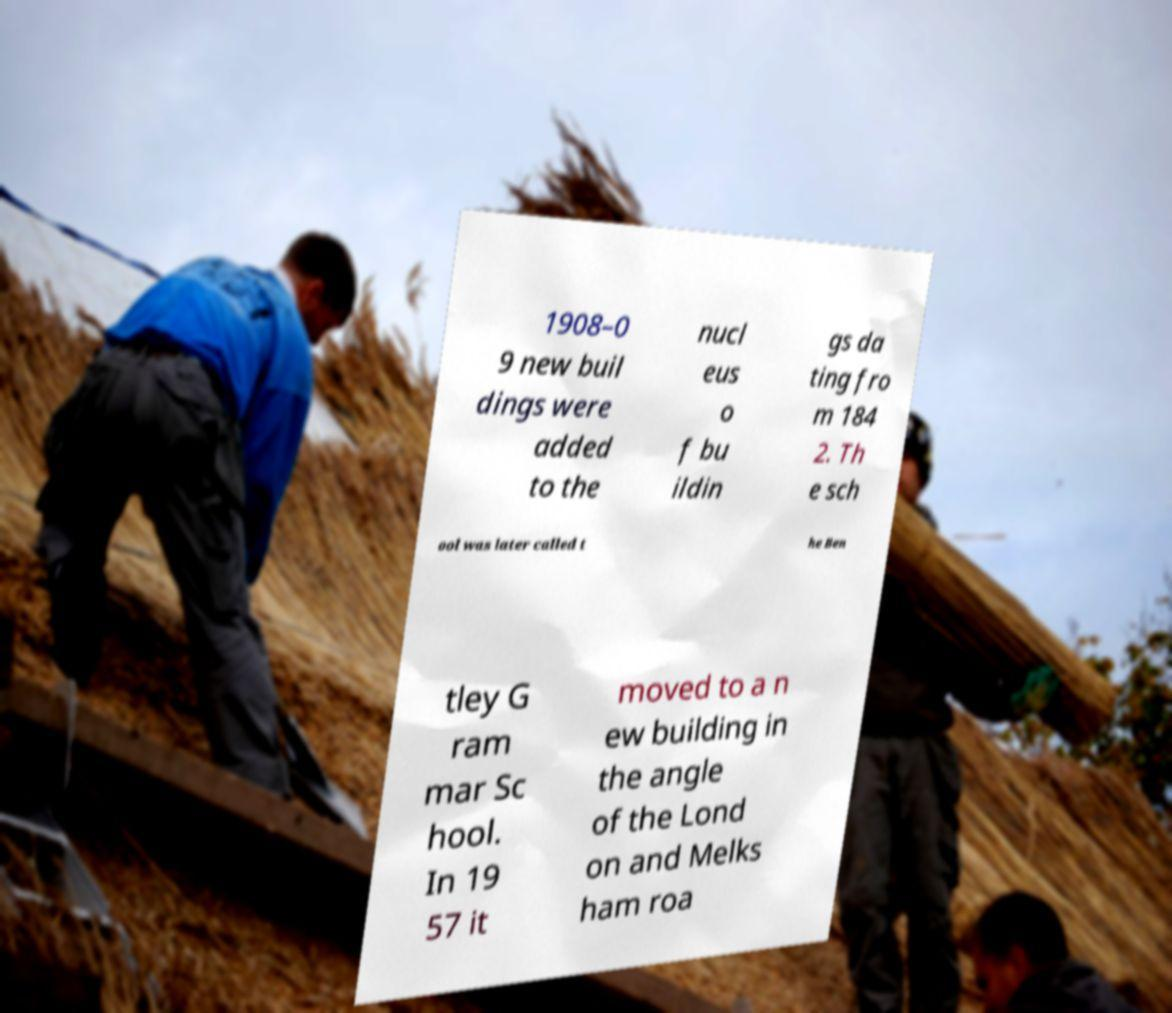What messages or text are displayed in this image? I need them in a readable, typed format. 1908–0 9 new buil dings were added to the nucl eus o f bu ildin gs da ting fro m 184 2. Th e sch ool was later called t he Ben tley G ram mar Sc hool. In 19 57 it moved to a n ew building in the angle of the Lond on and Melks ham roa 